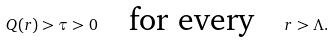<formula> <loc_0><loc_0><loc_500><loc_500>Q ( r ) > \tau > 0 \quad \text {for every} \quad r > \Lambda .</formula> 